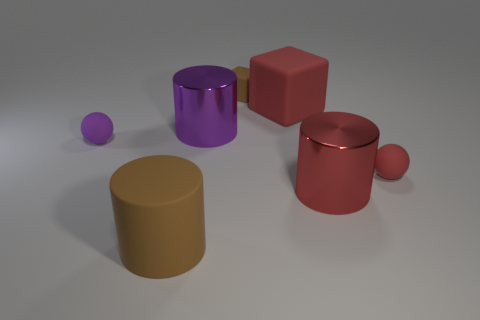Add 1 small purple balls. How many objects exist? 8 Subtract all cubes. How many objects are left? 5 Add 2 small blue metal balls. How many small blue metal balls exist? 2 Subtract 1 red cylinders. How many objects are left? 6 Subtract all big red matte blocks. Subtract all spheres. How many objects are left? 4 Add 4 large matte blocks. How many large matte blocks are left? 5 